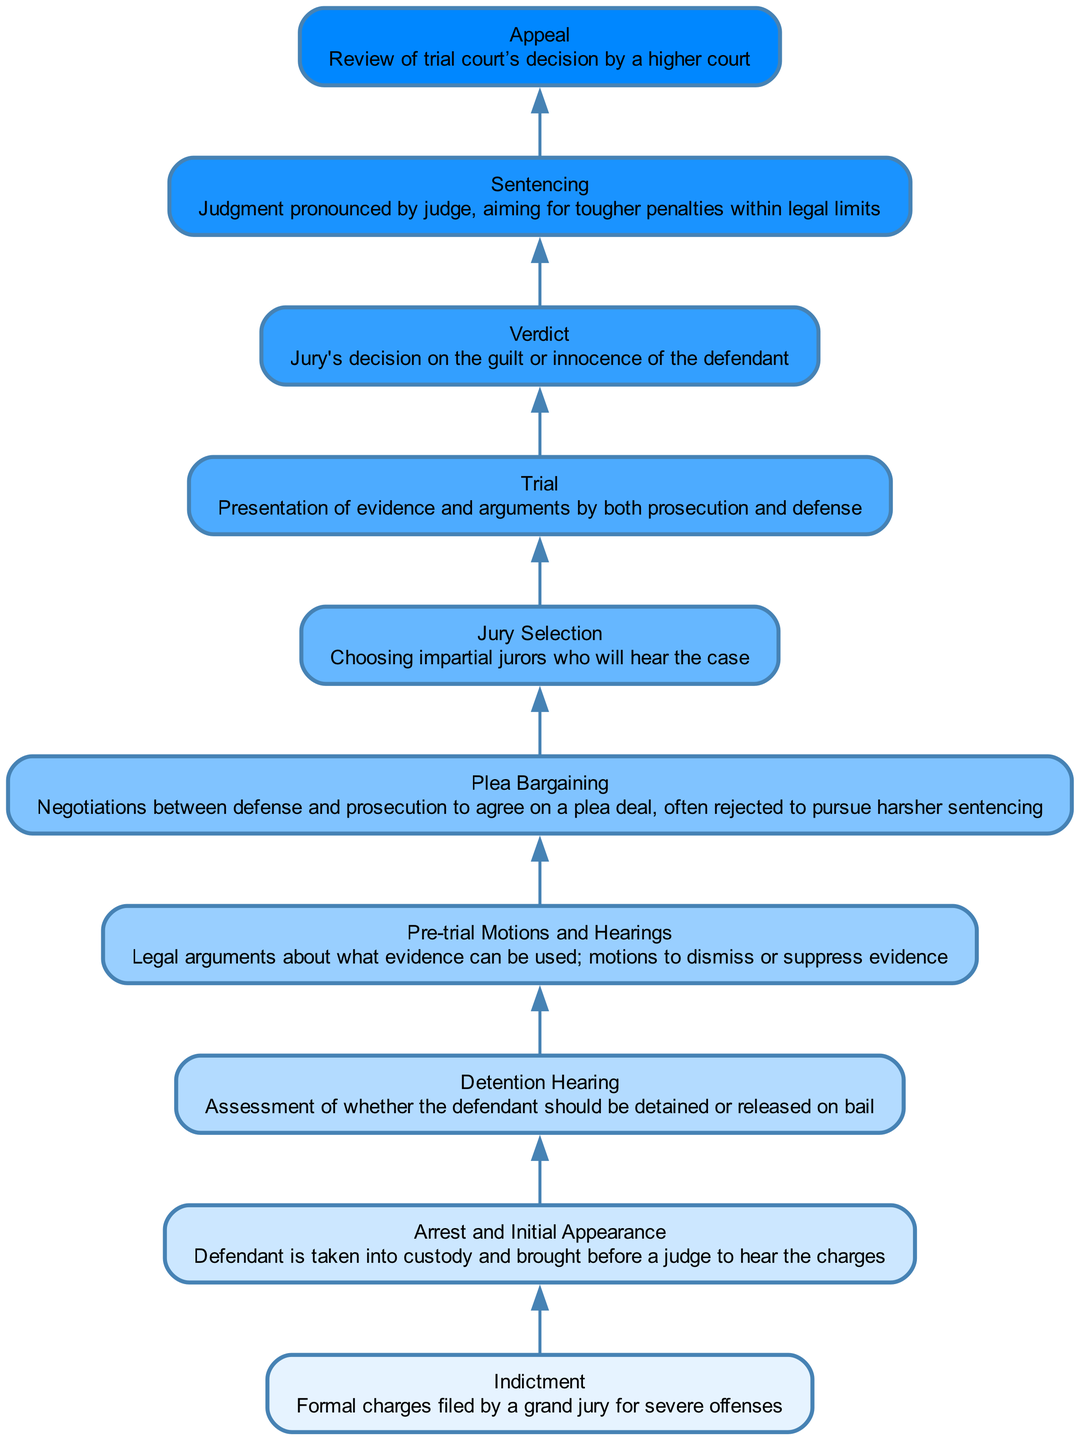What is the first step in the process? The diagram starts with the "Indictment" node, which represents the formal charges filed by a grand jury for severe offenses.
Answer: Indictment How many nodes are in the diagram? Counting all elements listed in the diagram, there are ten nodes, representing the various stages of handling high-profile cases.
Answer: 10 Which node comes directly after "Pre-trial Motions and Hearings"? Following "Pre-trial Motions and Hearings" is the "Plea Bargaining" node, indicating the negotiations following the pre-trial before jury selection.
Answer: Plea Bargaining What happens if the jury finds the defendant guilty? If the jury delivers a "Verdict" of guilty, the process proceeds to the "Sentencing" node, where the judge pronounces the judgment.
Answer: Sentencing What is the last step in the process? The final stage in the flowchart is the "Appeal," which represents the review of the trial court's decision by a higher court.
Answer: Appeal Which stage assesses whether the defendant should be released on bail? The "Detention Hearing" stage involves assessing whether the defendant should be detained or released on bail following the initial appearance.
Answer: Detention Hearing How many dependencies does the "Trial" step have? The "Trial" step has one dependency, which is "Jury Selection," highlighting that a jury must be selected before the trial can occur.
Answer: 1 What do the arrows between nodes signify? The arrows represent the dependencies or the flow of the process, indicating that each step must be completed before the next can begin.
Answer: Dependencies Which step involves defending against evidence in court? "Pre-trial Motions and Hearings" involves legal arguments regarding what evidence can be presented, such as motions to dismiss or suppress evidence.
Answer: Pre-trial Motions and Hearings 